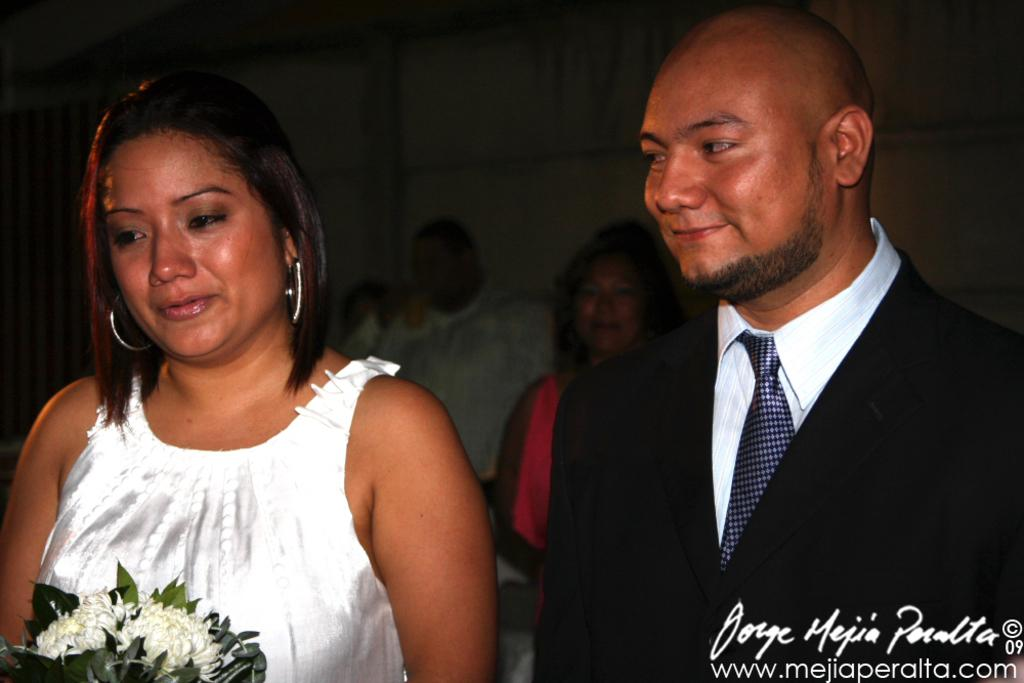What can be seen in the foreground of the image? There are people in the foreground of the image. Can you describe the clothing of one of the people in the foreground? One person in the foreground is wearing a white top. What is the person in the white top holding? The person in the white top is holding a flower vase. Can you describe the clothing of another person in the foreground? Another person in the foreground is wearing a black coat. What else can be seen in the image? There are people in the background of the image. What type of wren can be seen perched on the person's shoulder in the image? There is no wren present in the image; it only features people in various clothing and a person holding a flower vase. 